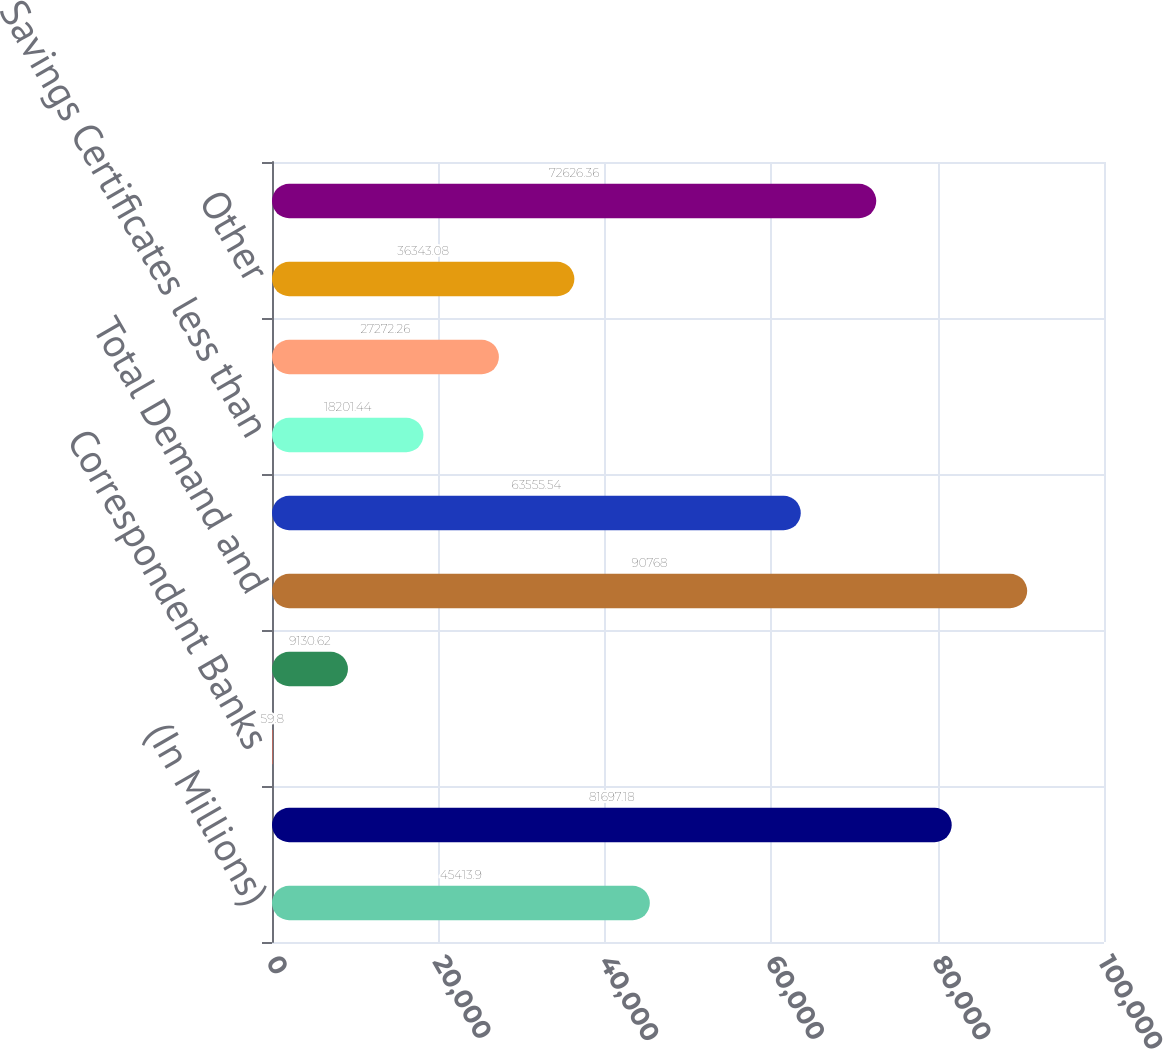Convert chart. <chart><loc_0><loc_0><loc_500><loc_500><bar_chart><fcel>(In Millions)<fcel>Individuals Partnerships and<fcel>Correspondent Banks<fcel>Other Noninterest-Bearing<fcel>Total Demand and<fcel>Savings and Money Market<fcel>Savings Certificates less than<fcel>Savings Certificates 100000<fcel>Other<fcel>Total Interest-Bearing<nl><fcel>45413.9<fcel>81697.2<fcel>59.8<fcel>9130.62<fcel>90768<fcel>63555.5<fcel>18201.4<fcel>27272.3<fcel>36343.1<fcel>72626.4<nl></chart> 